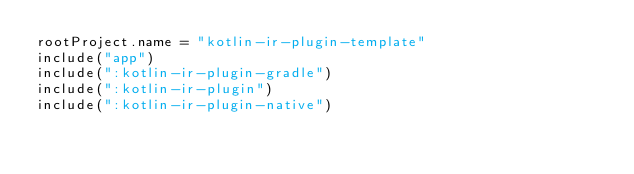Convert code to text. <code><loc_0><loc_0><loc_500><loc_500><_Kotlin_>rootProject.name = "kotlin-ir-plugin-template"
include("app")
include(":kotlin-ir-plugin-gradle")
include(":kotlin-ir-plugin")
include(":kotlin-ir-plugin-native")
</code> 